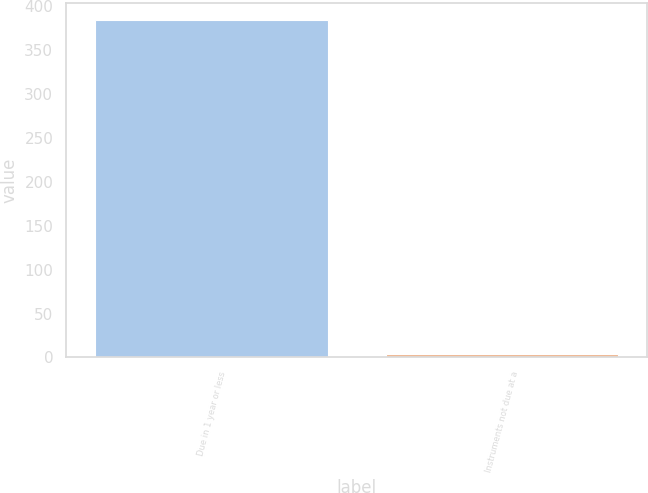Convert chart to OTSL. <chart><loc_0><loc_0><loc_500><loc_500><bar_chart><fcel>Due in 1 year or less<fcel>Instruments not due at a<nl><fcel>384.4<fcel>3.8<nl></chart> 